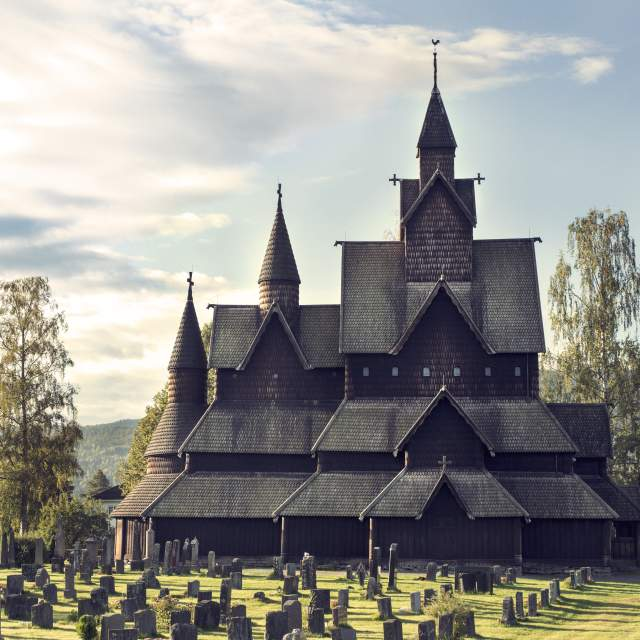As a filmmaker, how would you use this church as a location in a movie? As a filmmaker, Heddal Stave Church would serve as the perfect setting for a historical epic or a fantasy tale. Its dramatic architecture and the serene, yet mysterious surrounding landscape would be ideal for scenes of ancient rituals, mystical ceremonies, or pivotal moments of reflection and revelation. Imagine filming a medieval tale where the church serves as a refuge for knights, or a fantasy story where it becomes the site of a climactic battle between mystical forces. Its intricate woodwork and dark, towering spires would provide stunning visual contrast against scenes of fiery conflict or magical enchantment, making it a central character in its own right within the story. 